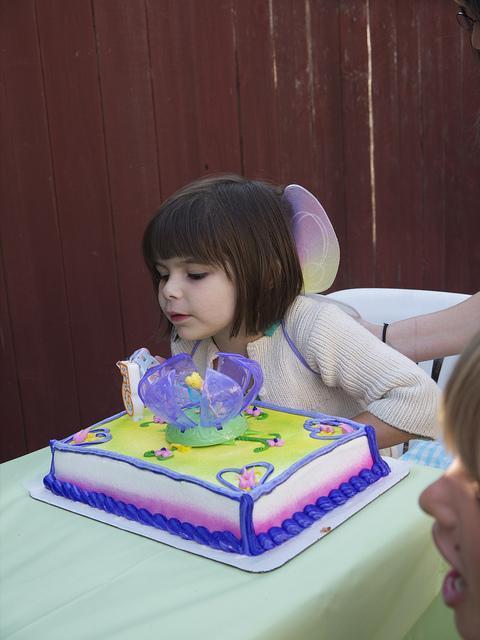How many people are visible?
Give a very brief answer. 3. How many horses are there?
Give a very brief answer. 0. 